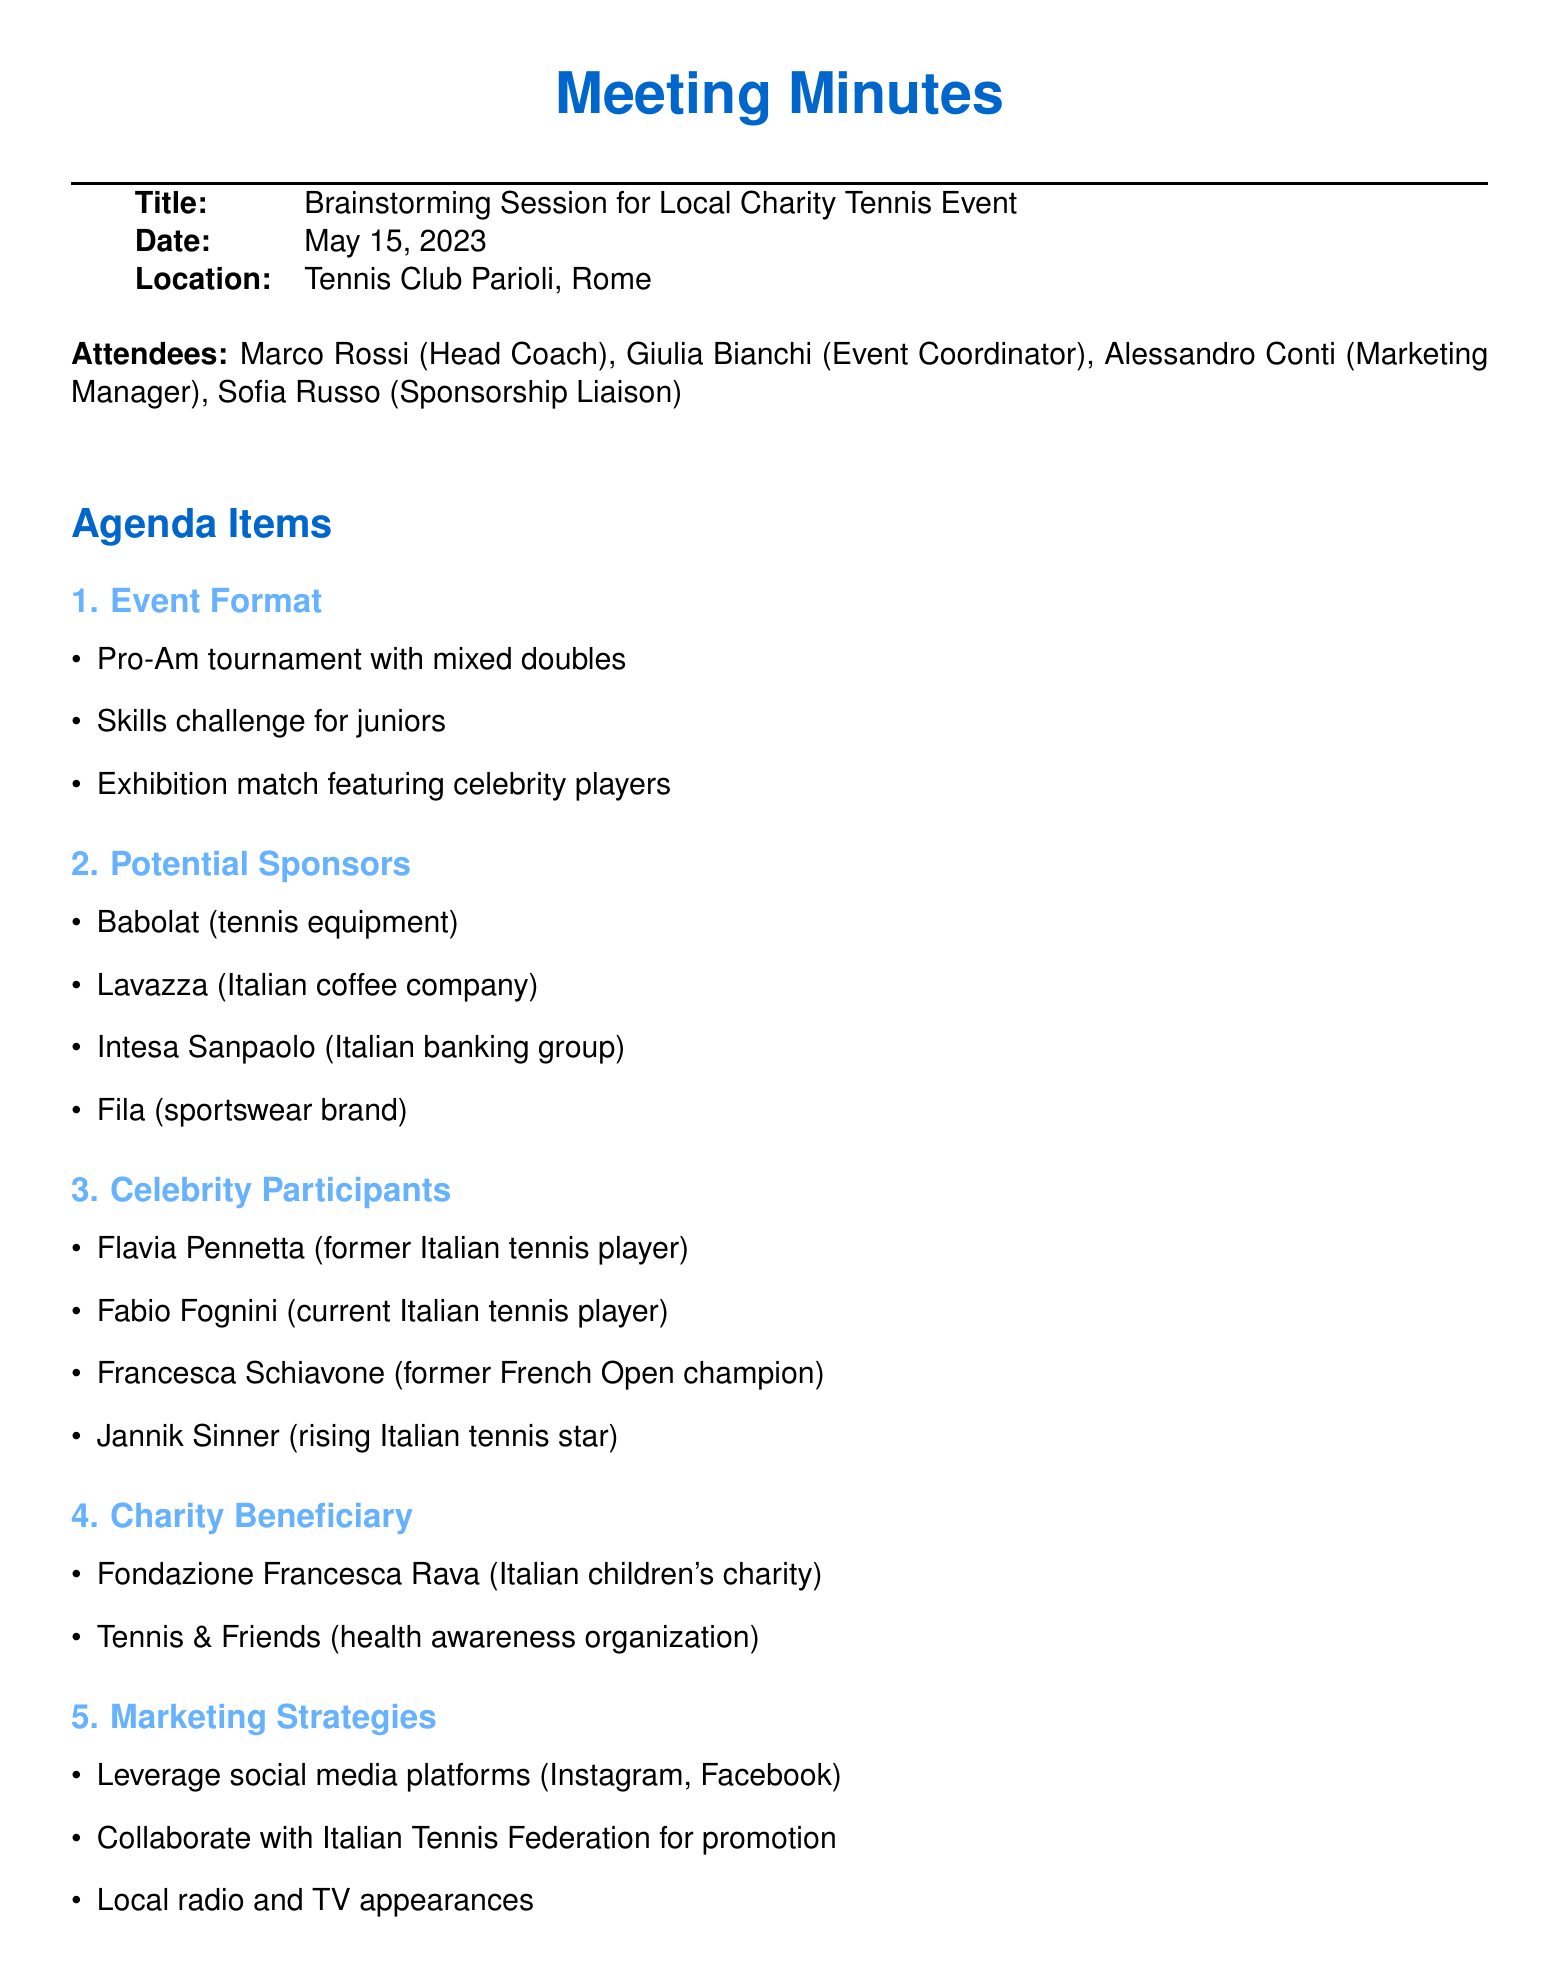What is the date of the meeting? The date of the meeting is mentioned directly in the document.
Answer: May 15, 2023 Who is the Event Coordinator? The document lists the attendees, including their roles, allowing for easy identification.
Answer: Giulia Bianchi What type of charity is the event benefiting? The document specifies the charity organizations chosen as beneficiaries.
Answer: Italian children's charity Name one of the celebrity participants. The list of celebrity participants is provided in the document, allowing for the retrieval of specific names.
Answer: Flavia Pennetta What is one of the marketing strategies mentioned? The document outlines several marketing strategies during the meeting discussion.
Answer: Leverage social media platforms How many sponsors are listed in the document? By counting the sponsors in the section, one can find the answer efficiently.
Answer: Four What is the location of the event? The location is explicitly stated in the document, making it easily retrievable.
Answer: Tennis Club Parioli, Rome What type of tournament format is planned? The format of the tournament is discussed in the agenda items, providing clear details.
Answer: Pro-Am tournament with mixed doubles 